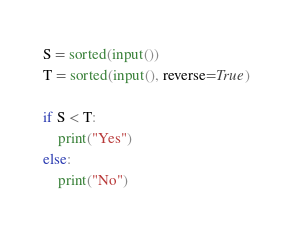Convert code to text. <code><loc_0><loc_0><loc_500><loc_500><_Python_>S = sorted(input())
T = sorted(input(), reverse=True)

if S < T:
    print("Yes")
else:
    print("No")
</code> 